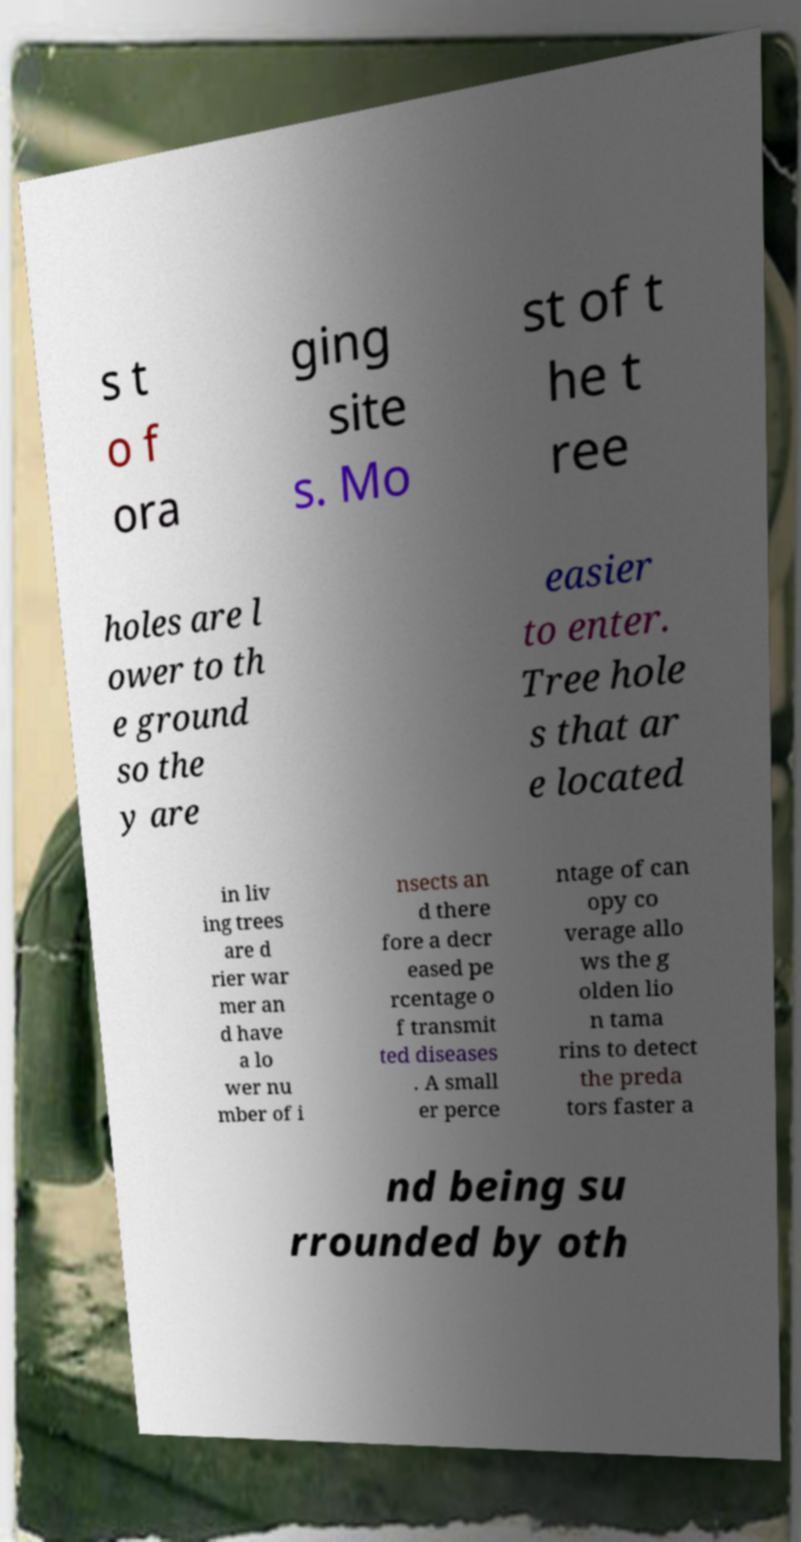What messages or text are displayed in this image? I need them in a readable, typed format. s t o f ora ging site s. Mo st of t he t ree holes are l ower to th e ground so the y are easier to enter. Tree hole s that ar e located in liv ing trees are d rier war mer an d have a lo wer nu mber of i nsects an d there fore a decr eased pe rcentage o f transmit ted diseases . A small er perce ntage of can opy co verage allo ws the g olden lio n tama rins to detect the preda tors faster a nd being su rrounded by oth 